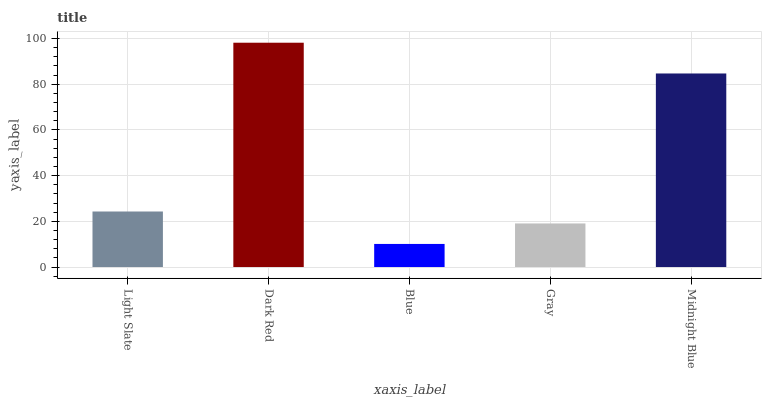Is Blue the minimum?
Answer yes or no. Yes. Is Dark Red the maximum?
Answer yes or no. Yes. Is Dark Red the minimum?
Answer yes or no. No. Is Blue the maximum?
Answer yes or no. No. Is Dark Red greater than Blue?
Answer yes or no. Yes. Is Blue less than Dark Red?
Answer yes or no. Yes. Is Blue greater than Dark Red?
Answer yes or no. No. Is Dark Red less than Blue?
Answer yes or no. No. Is Light Slate the high median?
Answer yes or no. Yes. Is Light Slate the low median?
Answer yes or no. Yes. Is Blue the high median?
Answer yes or no. No. Is Dark Red the low median?
Answer yes or no. No. 